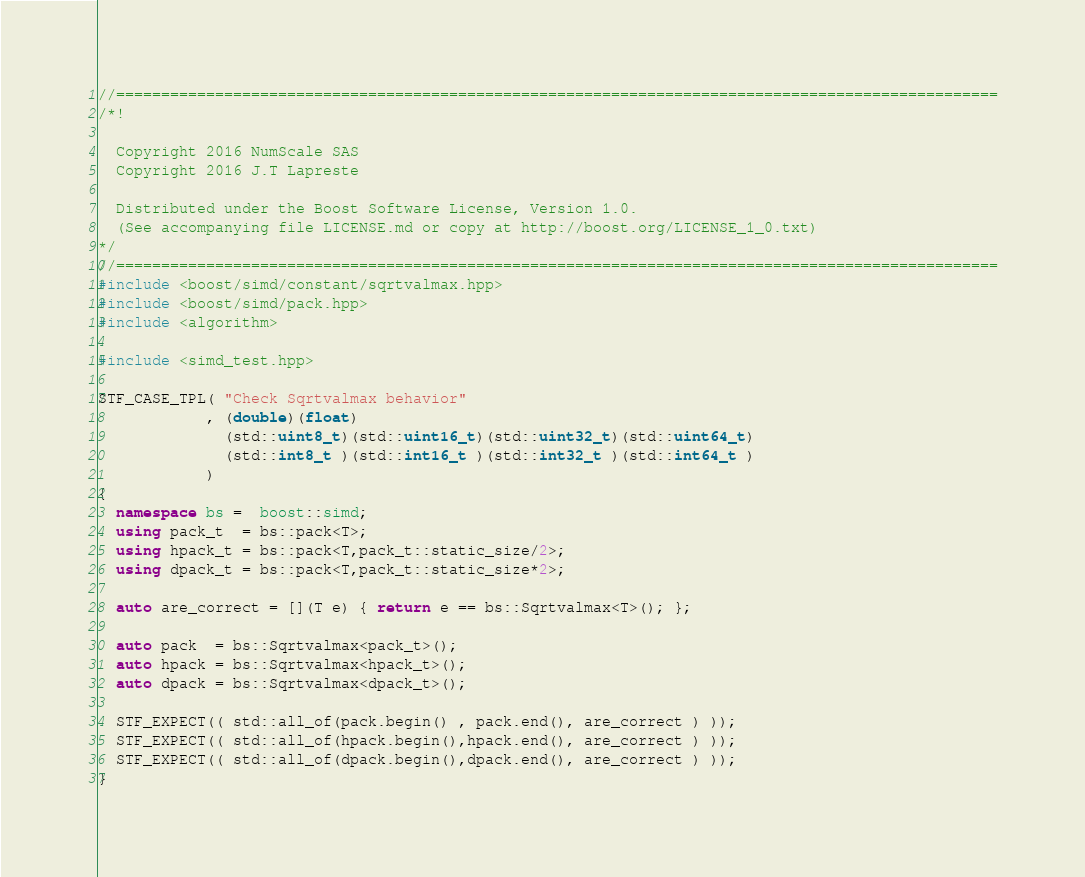<code> <loc_0><loc_0><loc_500><loc_500><_C++_>//==================================================================================================
/*!

  Copyright 2016 NumScale SAS
  Copyright 2016 J.T Lapreste

  Distributed under the Boost Software License, Version 1.0.
  (See accompanying file LICENSE.md or copy at http://boost.org/LICENSE_1_0.txt)
*/
//==================================================================================================
#include <boost/simd/constant/sqrtvalmax.hpp>
#include <boost/simd/pack.hpp>
#include <algorithm>

#include <simd_test.hpp>

STF_CASE_TPL( "Check Sqrtvalmax behavior"
            , (double)(float)
              (std::uint8_t)(std::uint16_t)(std::uint32_t)(std::uint64_t)
              (std::int8_t )(std::int16_t )(std::int32_t )(std::int64_t )
            )
{
  namespace bs =  boost::simd;
  using pack_t  = bs::pack<T>;
  using hpack_t = bs::pack<T,pack_t::static_size/2>;
  using dpack_t = bs::pack<T,pack_t::static_size*2>;

  auto are_correct = [](T e) { return e == bs::Sqrtvalmax<T>(); };

  auto pack  = bs::Sqrtvalmax<pack_t>();
  auto hpack = bs::Sqrtvalmax<hpack_t>();
  auto dpack = bs::Sqrtvalmax<dpack_t>();

  STF_EXPECT(( std::all_of(pack.begin() , pack.end(), are_correct ) ));
  STF_EXPECT(( std::all_of(hpack.begin(),hpack.end(), are_correct ) ));
  STF_EXPECT(( std::all_of(dpack.begin(),dpack.end(), are_correct ) ));
}
</code> 